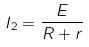<formula> <loc_0><loc_0><loc_500><loc_500>I _ { 2 } = \frac { E } { R + r }</formula> 